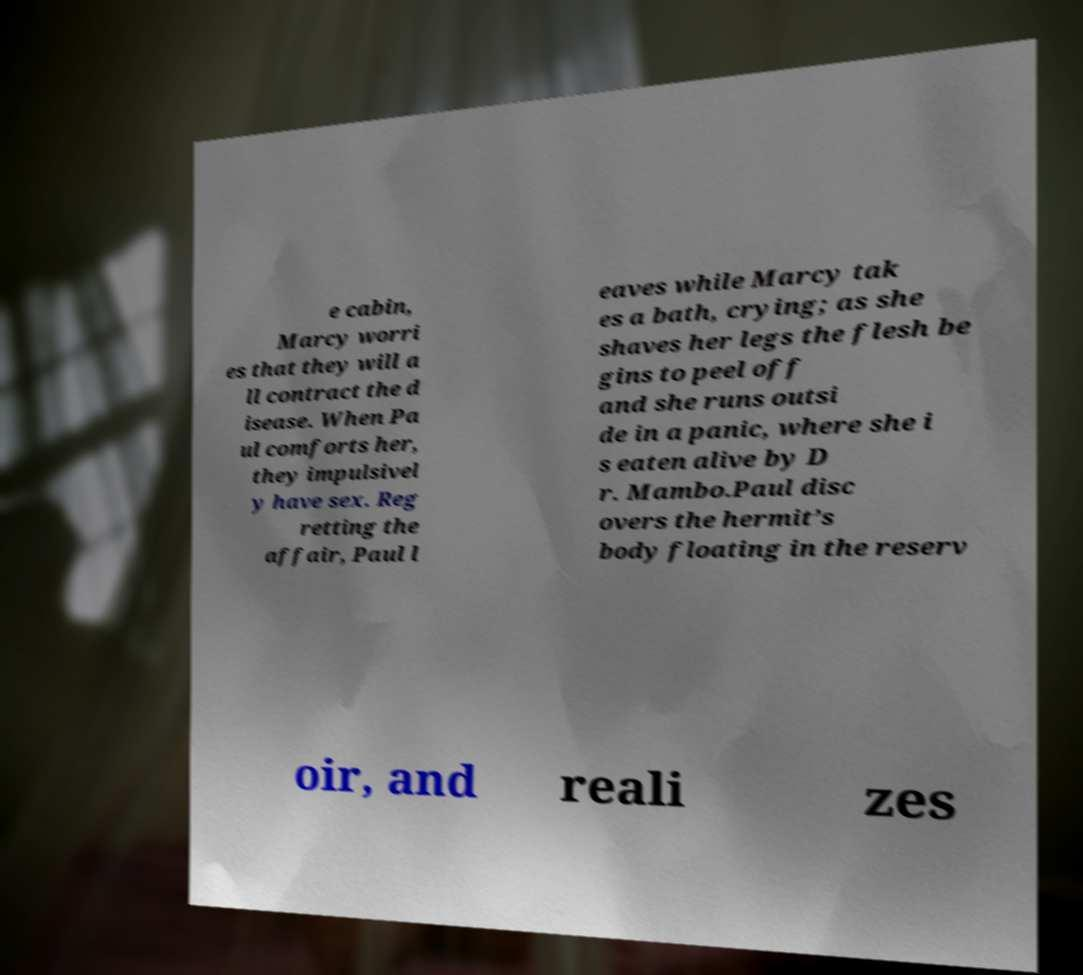Can you accurately transcribe the text from the provided image for me? e cabin, Marcy worri es that they will a ll contract the d isease. When Pa ul comforts her, they impulsivel y have sex. Reg retting the affair, Paul l eaves while Marcy tak es a bath, crying; as she shaves her legs the flesh be gins to peel off and she runs outsi de in a panic, where she i s eaten alive by D r. Mambo.Paul disc overs the hermit’s body floating in the reserv oir, and reali zes 